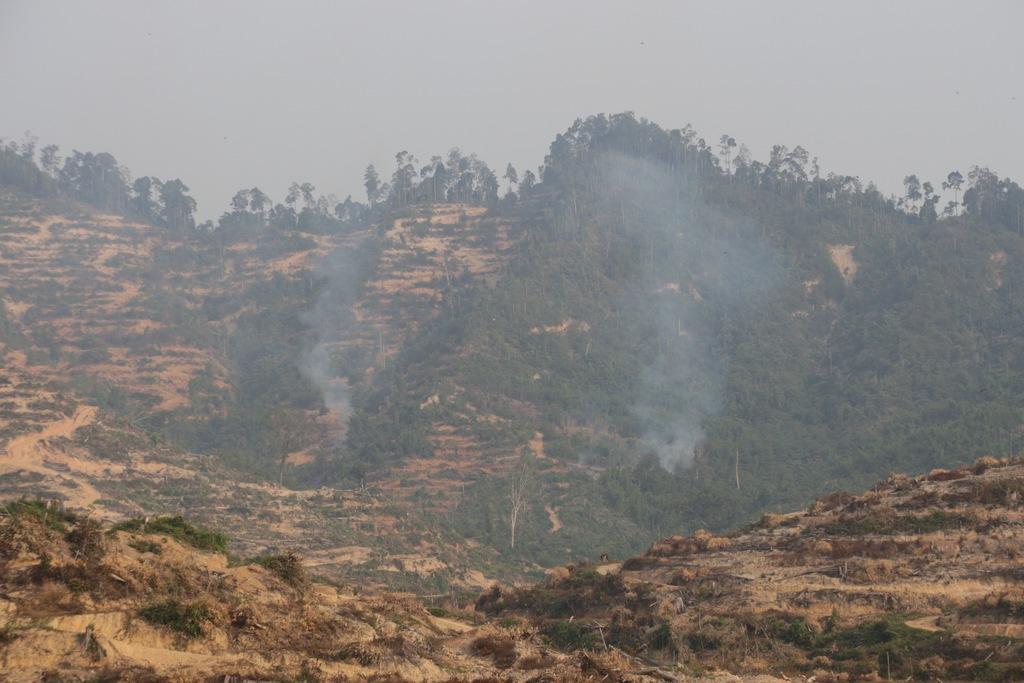Can you describe this image briefly? There is a hill with trees and smoke. In the background there is sky. 